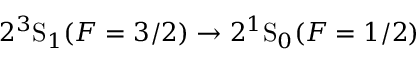<formula> <loc_0><loc_0><loc_500><loc_500>2 ^ { 3 } S _ { 1 } ( F = 3 / 2 ) \rightarrow 2 ^ { 1 } S _ { 0 } ( F = 1 / 2 )</formula> 